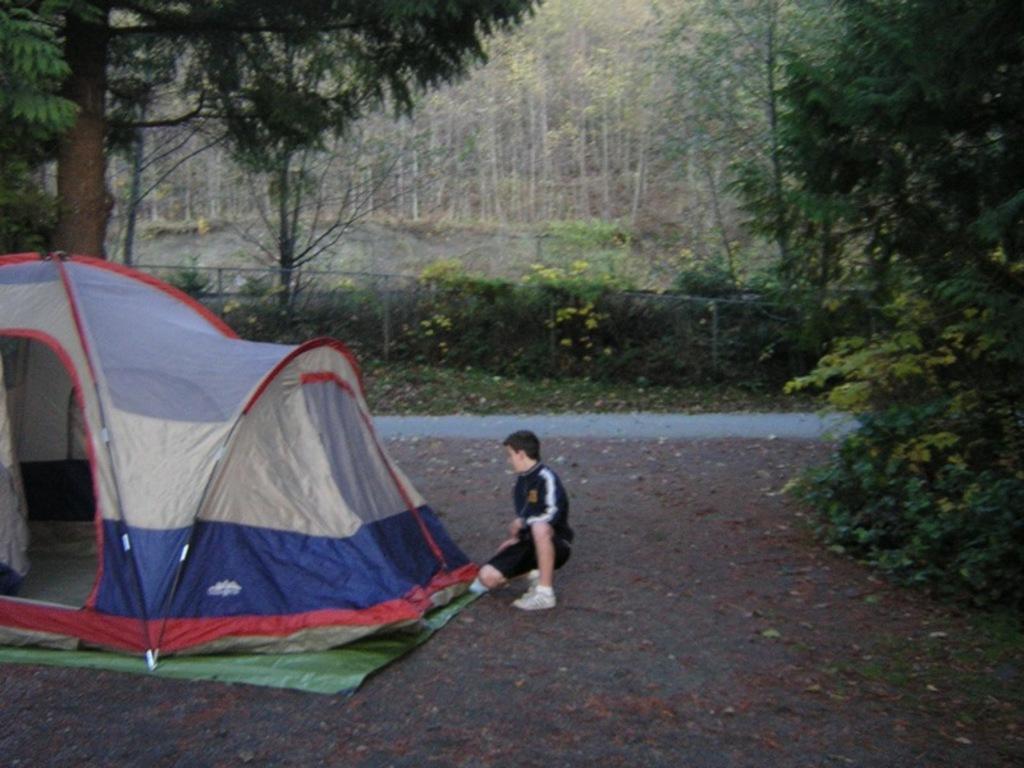Please provide a concise description of this image. On the left side, there is a tent on the ground. Beside this tent, there is a person in black color dress. On the right side, there is a tree. In the background, there is a road, there are trees and plants which are having flowers 